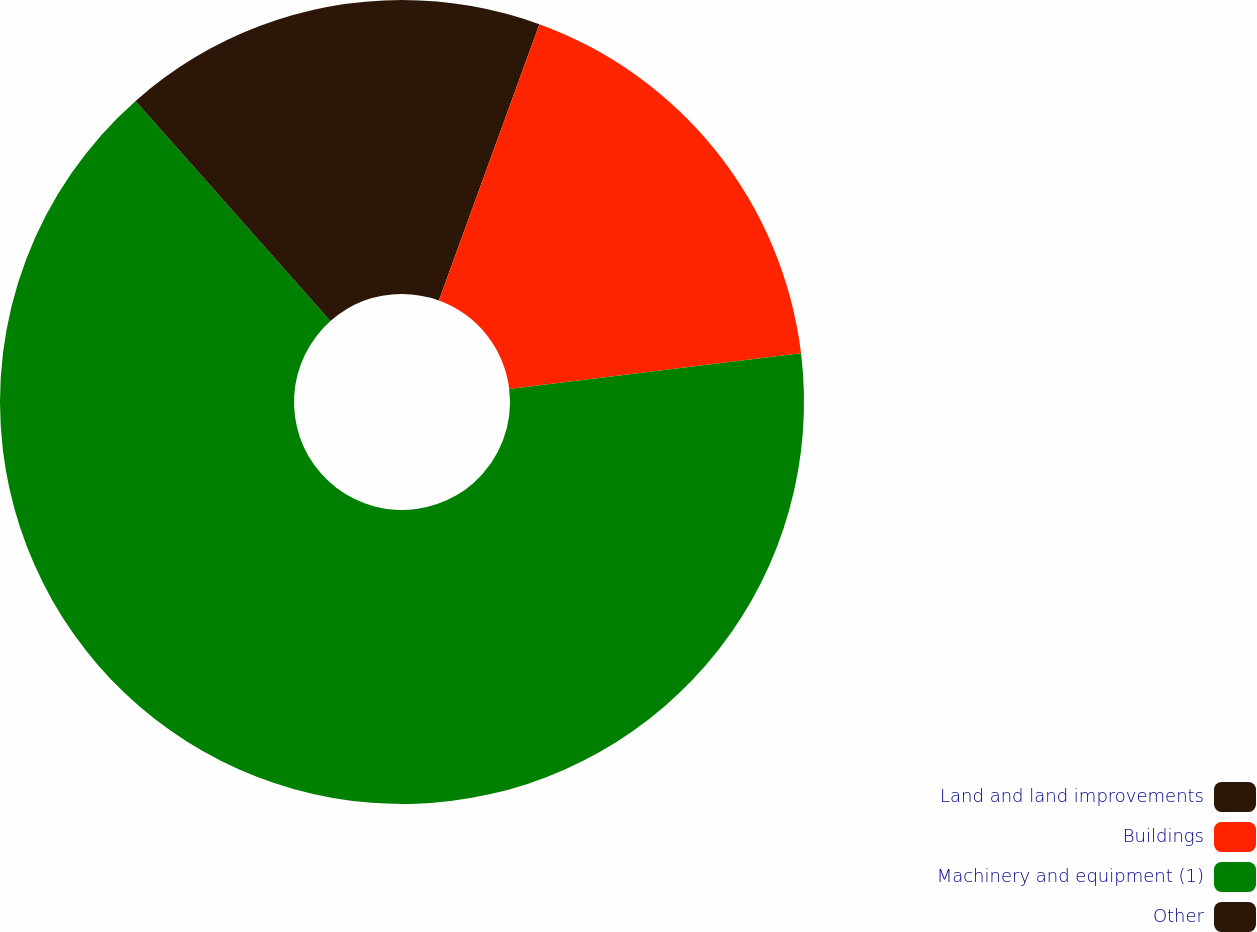<chart> <loc_0><loc_0><loc_500><loc_500><pie_chart><fcel>Land and land improvements<fcel>Buildings<fcel>Machinery and equipment (1)<fcel>Other<nl><fcel>5.55%<fcel>17.52%<fcel>65.4%<fcel>11.53%<nl></chart> 